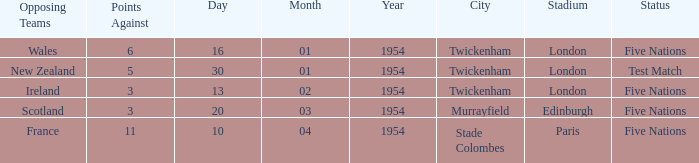What is the status when the against is 11? Five Nations. 